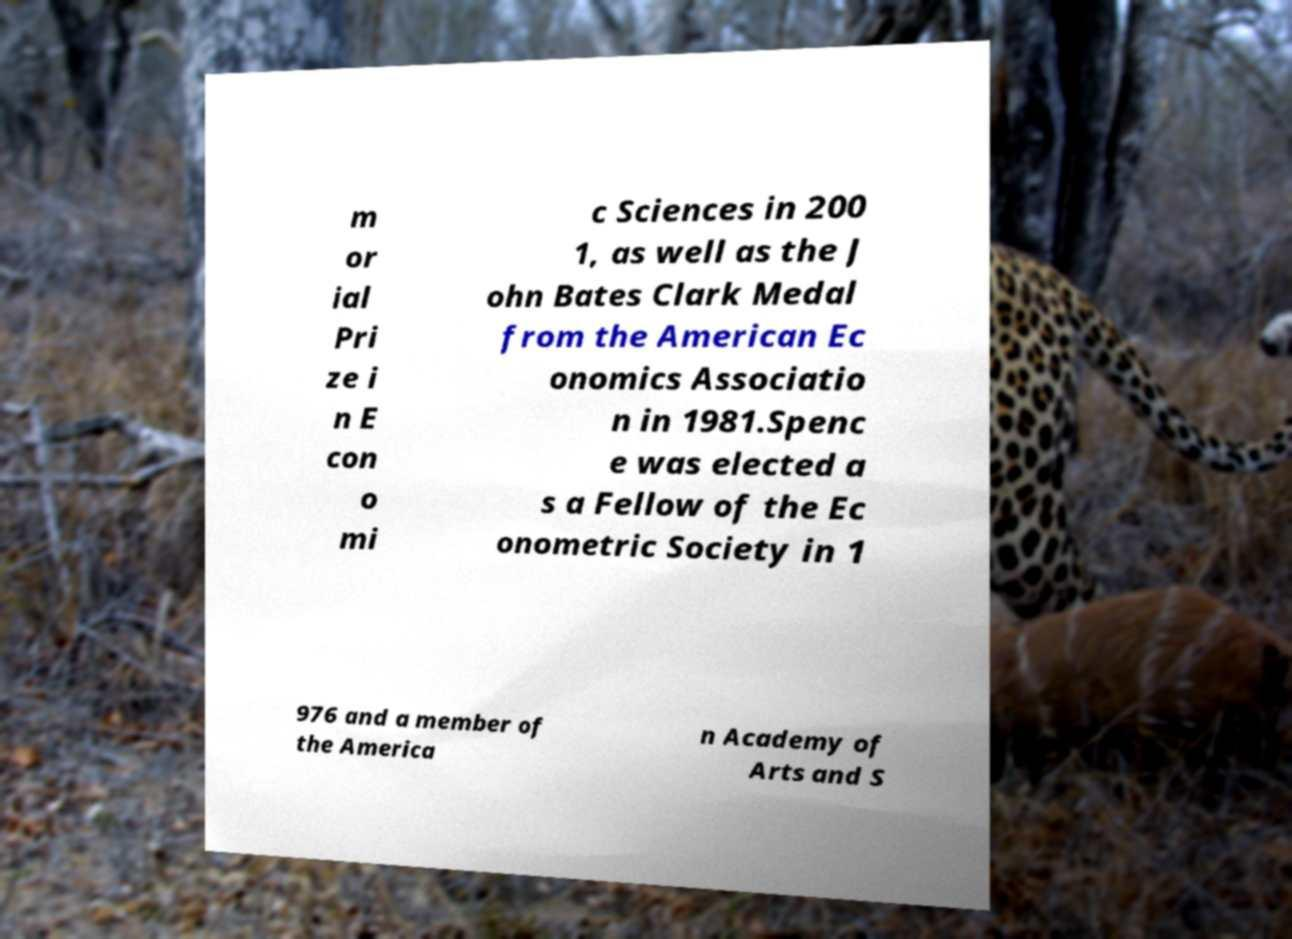Could you extract and type out the text from this image? m or ial Pri ze i n E con o mi c Sciences in 200 1, as well as the J ohn Bates Clark Medal from the American Ec onomics Associatio n in 1981.Spenc e was elected a s a Fellow of the Ec onometric Society in 1 976 and a member of the America n Academy of Arts and S 